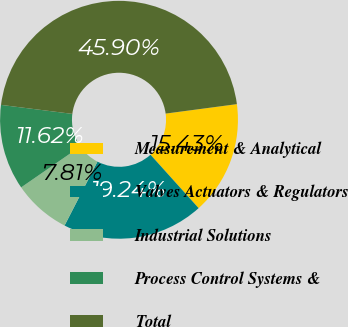Convert chart to OTSL. <chart><loc_0><loc_0><loc_500><loc_500><pie_chart><fcel>Measurement & Analytical<fcel>Valves Actuators & Regulators<fcel>Industrial Solutions<fcel>Process Control Systems &<fcel>Total<nl><fcel>15.43%<fcel>19.24%<fcel>7.81%<fcel>11.62%<fcel>45.9%<nl></chart> 